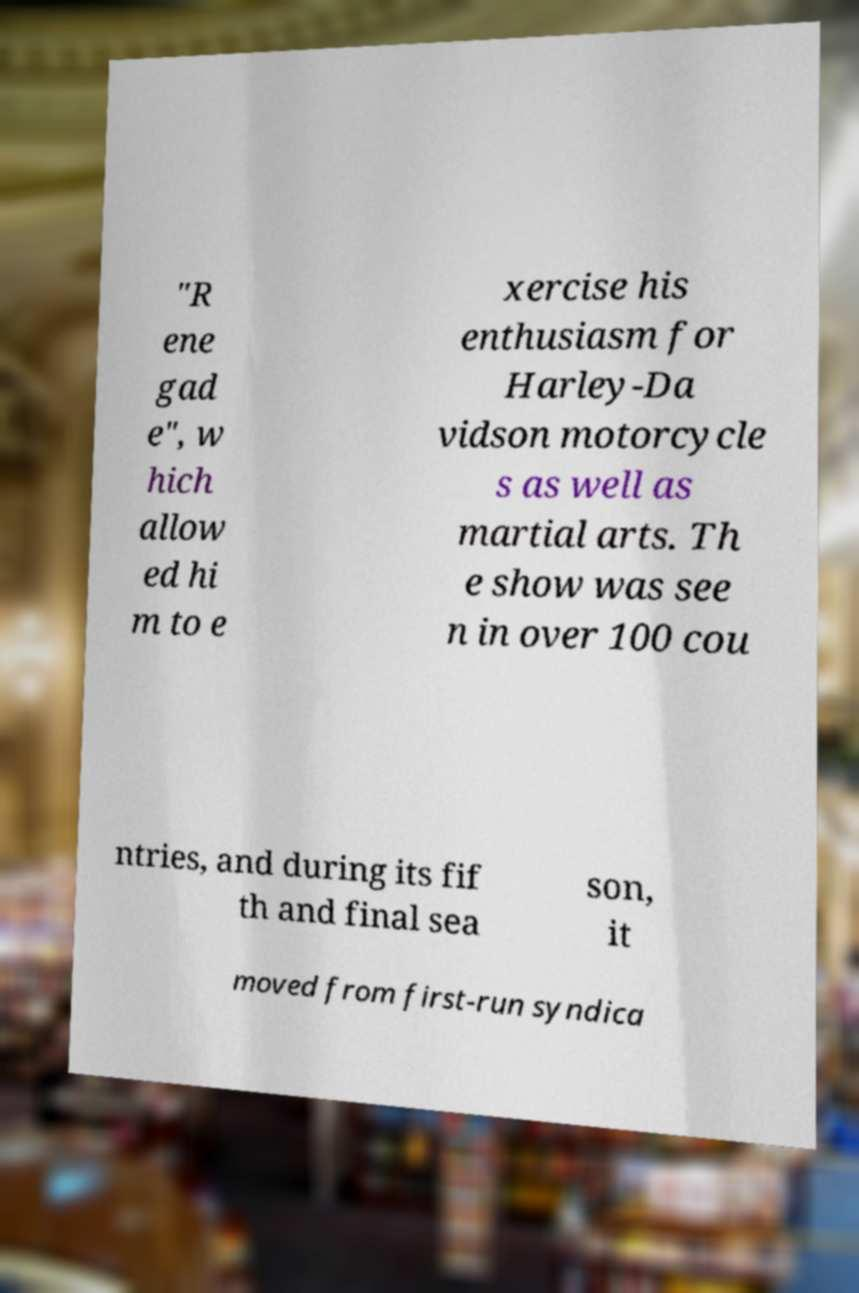What messages or text are displayed in this image? I need them in a readable, typed format. "R ene gad e", w hich allow ed hi m to e xercise his enthusiasm for Harley-Da vidson motorcycle s as well as martial arts. Th e show was see n in over 100 cou ntries, and during its fif th and final sea son, it moved from first-run syndica 